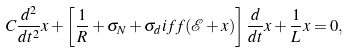<formula> <loc_0><loc_0><loc_500><loc_500>C \frac { d ^ { 2 } } { d t ^ { 2 } } x + \left [ \frac { 1 } { R } + \sigma _ { N } + \sigma _ { d } i f f ( \mathcal { E } + x ) \right ] \frac { d } { d t } x + \frac { 1 } { L } x = 0 ,</formula> 